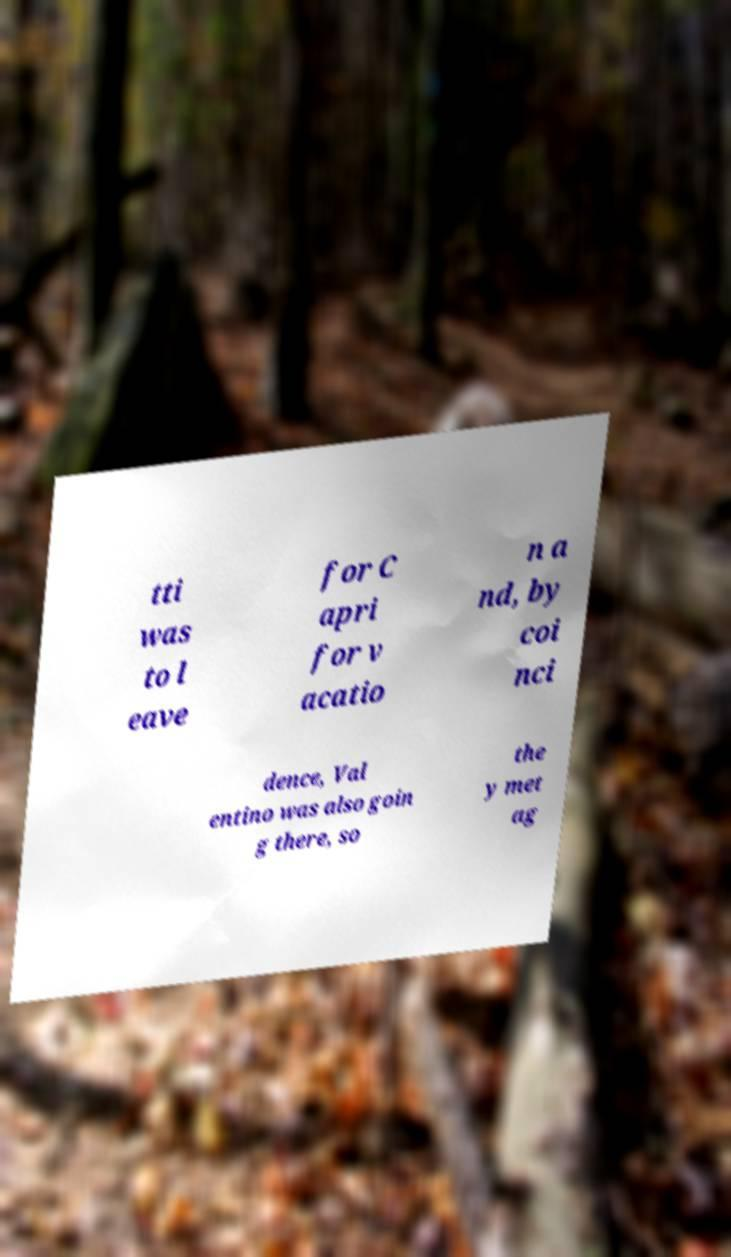There's text embedded in this image that I need extracted. Can you transcribe it verbatim? tti was to l eave for C apri for v acatio n a nd, by coi nci dence, Val entino was also goin g there, so the y met ag 